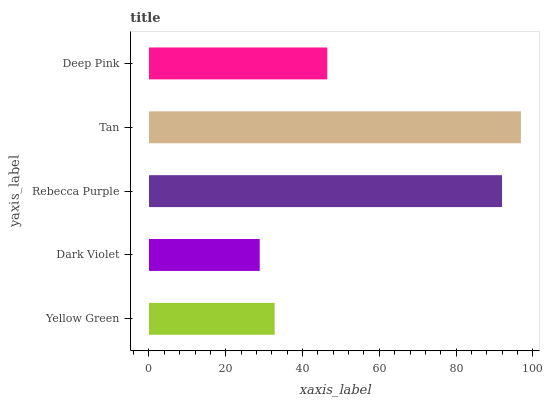Is Dark Violet the minimum?
Answer yes or no. Yes. Is Tan the maximum?
Answer yes or no. Yes. Is Rebecca Purple the minimum?
Answer yes or no. No. Is Rebecca Purple the maximum?
Answer yes or no. No. Is Rebecca Purple greater than Dark Violet?
Answer yes or no. Yes. Is Dark Violet less than Rebecca Purple?
Answer yes or no. Yes. Is Dark Violet greater than Rebecca Purple?
Answer yes or no. No. Is Rebecca Purple less than Dark Violet?
Answer yes or no. No. Is Deep Pink the high median?
Answer yes or no. Yes. Is Deep Pink the low median?
Answer yes or no. Yes. Is Tan the high median?
Answer yes or no. No. Is Yellow Green the low median?
Answer yes or no. No. 